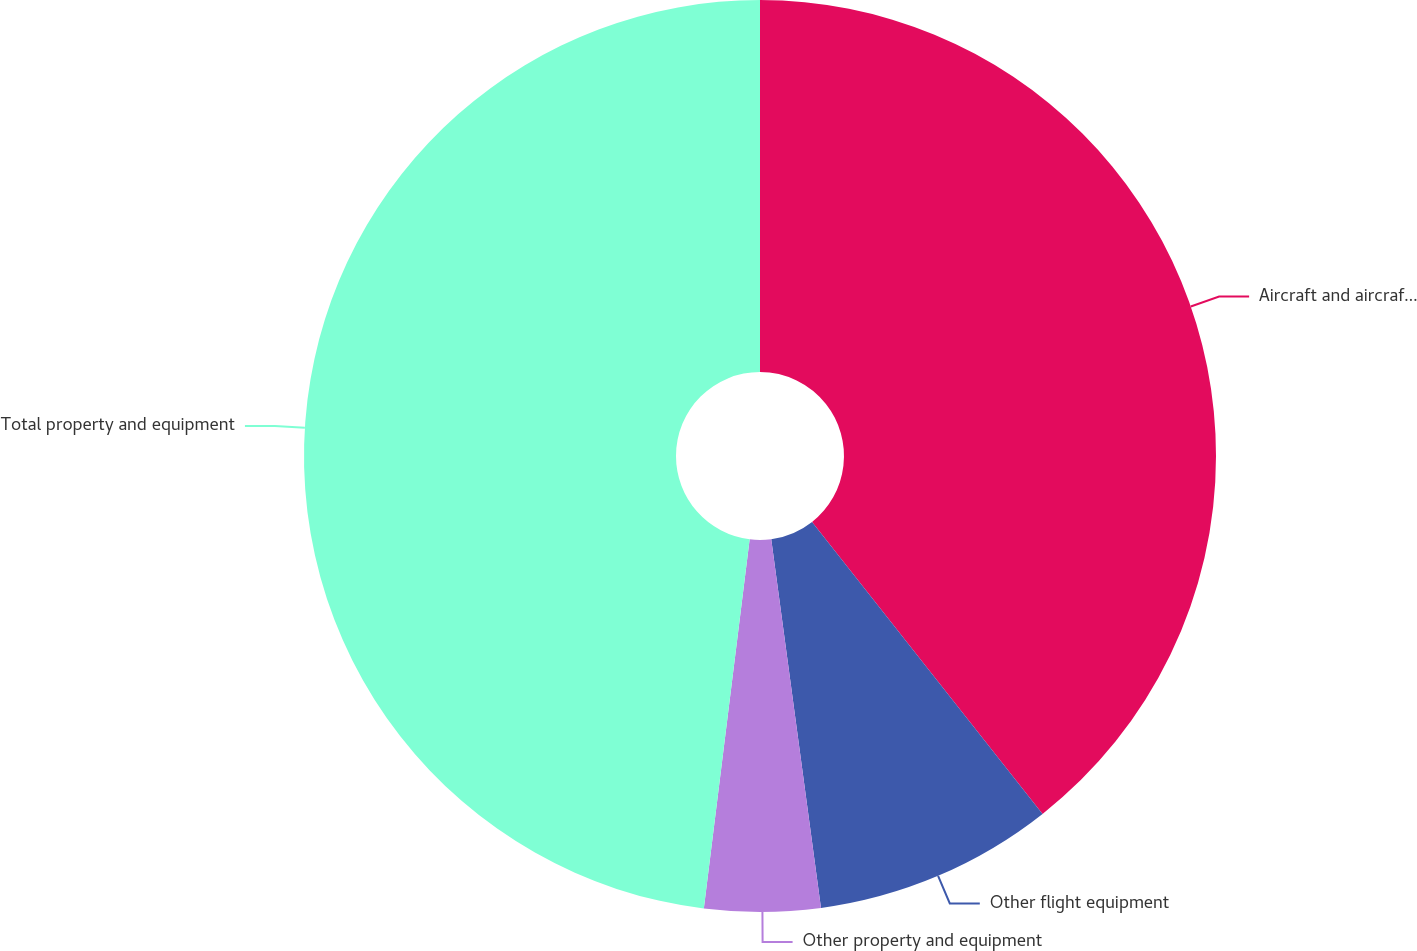Convert chart. <chart><loc_0><loc_0><loc_500><loc_500><pie_chart><fcel>Aircraft and aircraft purchase<fcel>Other flight equipment<fcel>Other property and equipment<fcel>Total property and equipment<nl><fcel>39.36%<fcel>8.5%<fcel>4.1%<fcel>48.03%<nl></chart> 